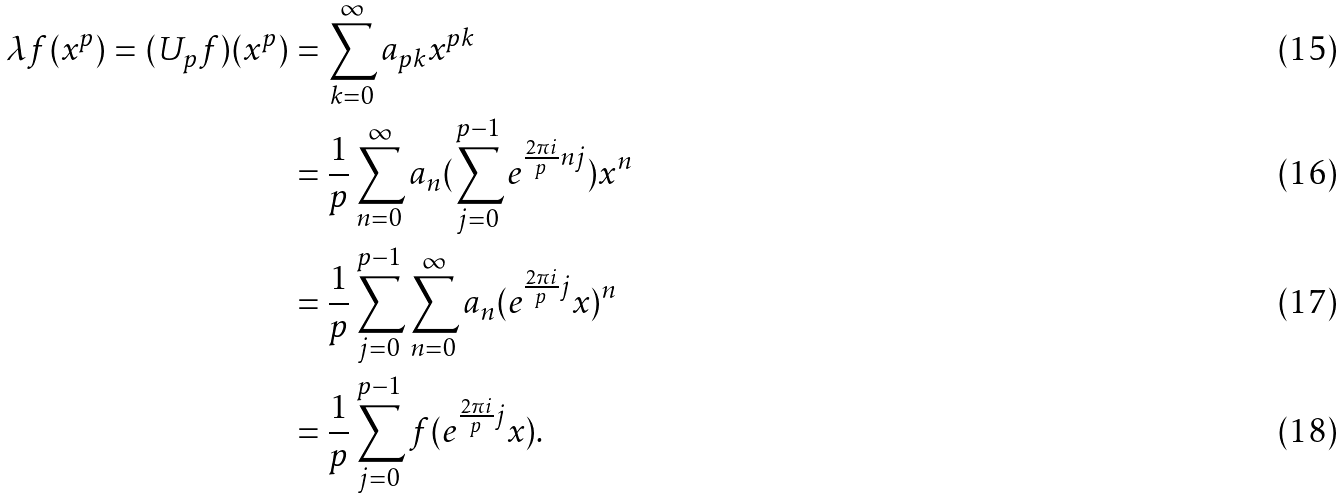<formula> <loc_0><loc_0><loc_500><loc_500>\lambda f ( x ^ { p } ) = ( U _ { p } f ) ( x ^ { p } ) & = \sum _ { k = 0 } ^ { \infty } a _ { p k } x ^ { p k } \\ & = \frac { 1 } { p } \sum _ { n = 0 } ^ { \infty } a _ { n } ( \sum _ { j = 0 } ^ { p - 1 } e ^ { \frac { 2 \pi i } { p } n j } ) x ^ { n } \\ & = \frac { 1 } { p } \sum _ { j = 0 } ^ { p - 1 } \sum _ { n = 0 } ^ { \infty } a _ { n } ( e ^ { \frac { 2 \pi i } { p } j } x ) ^ { n } \\ & = \frac { 1 } { p } \sum _ { j = 0 } ^ { p - 1 } f ( e ^ { \frac { 2 \pi i } { p } j } x ) .</formula> 